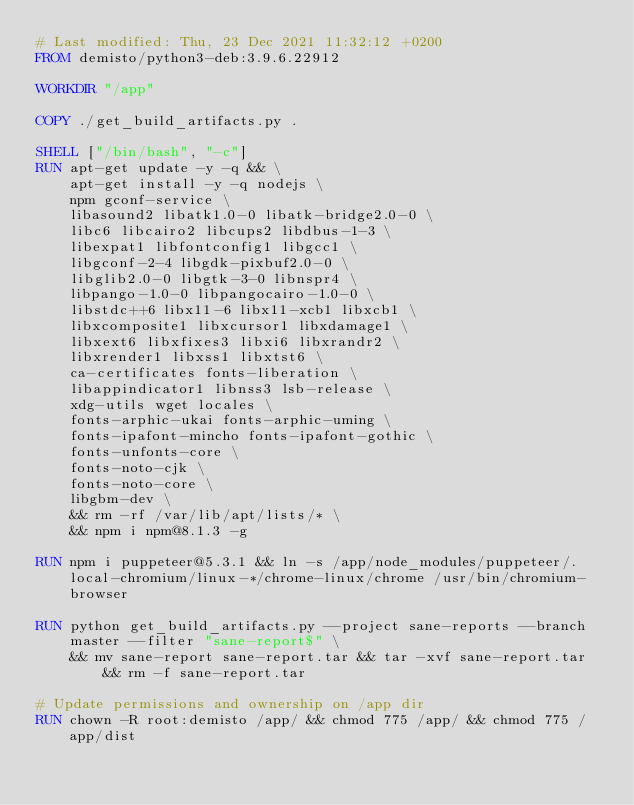<code> <loc_0><loc_0><loc_500><loc_500><_Dockerfile_># Last modified: Thu, 23 Dec 2021 11:32:12 +0200
FROM demisto/python3-deb:3.9.6.22912

WORKDIR "/app"

COPY ./get_build_artifacts.py .

SHELL ["/bin/bash", "-c"]
RUN apt-get update -y -q && \
    apt-get install -y -q nodejs \
    npm gconf-service \
    libasound2 libatk1.0-0 libatk-bridge2.0-0 \
    libc6 libcairo2 libcups2 libdbus-1-3 \
    libexpat1 libfontconfig1 libgcc1 \
    libgconf-2-4 libgdk-pixbuf2.0-0 \
    libglib2.0-0 libgtk-3-0 libnspr4 \
    libpango-1.0-0 libpangocairo-1.0-0 \
    libstdc++6 libx11-6 libx11-xcb1 libxcb1 \
    libxcomposite1 libxcursor1 libxdamage1 \
    libxext6 libxfixes3 libxi6 libxrandr2 \
    libxrender1 libxss1 libxtst6 \
    ca-certificates fonts-liberation \
    libappindicator1 libnss3 lsb-release \
    xdg-utils wget locales \
    fonts-arphic-ukai fonts-arphic-uming \
    fonts-ipafont-mincho fonts-ipafont-gothic \
    fonts-unfonts-core \
    fonts-noto-cjk \
    fonts-noto-core \
    libgbm-dev \
    && rm -rf /var/lib/apt/lists/* \
    && npm i npm@8.1.3 -g

RUN npm i puppeteer@5.3.1 && ln -s /app/node_modules/puppeteer/.local-chromium/linux-*/chrome-linux/chrome /usr/bin/chromium-browser

RUN python get_build_artifacts.py --project sane-reports --branch master --filter "sane-report$" \
    && mv sane-report sane-report.tar && tar -xvf sane-report.tar && rm -f sane-report.tar

# Update permissions and ownership on /app dir
RUN chown -R root:demisto /app/ && chmod 775 /app/ && chmod 775 /app/dist
</code> 